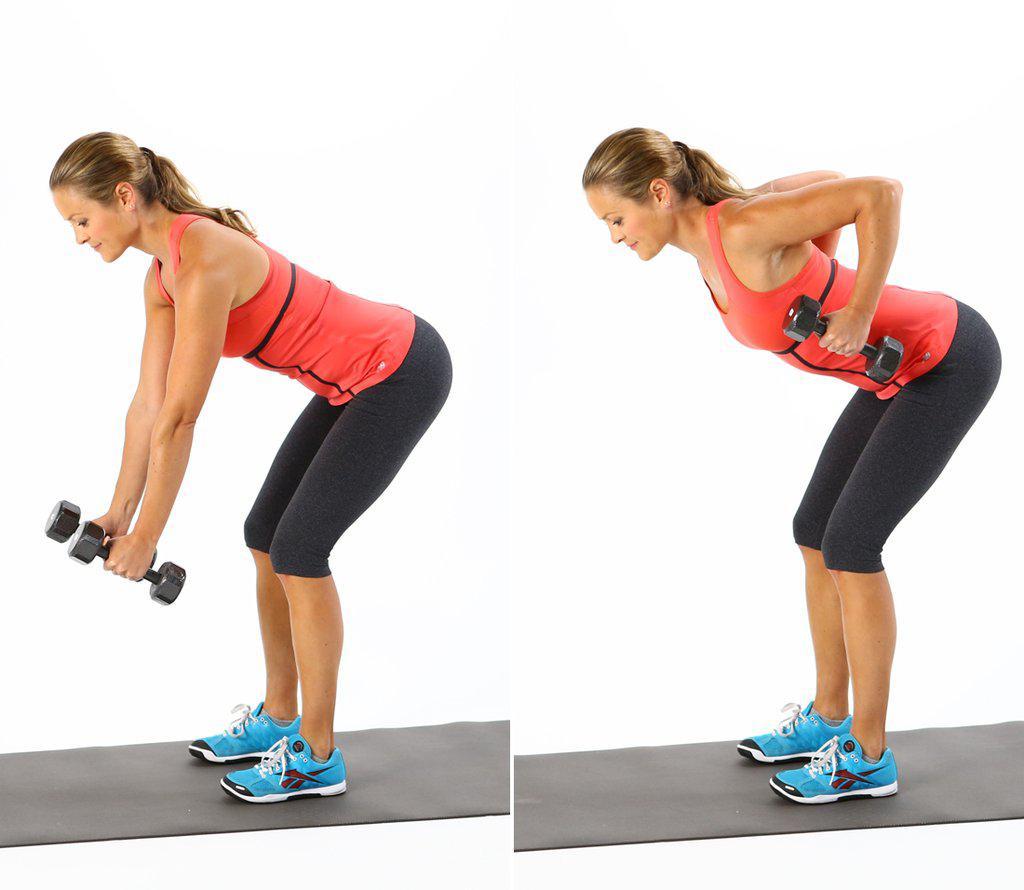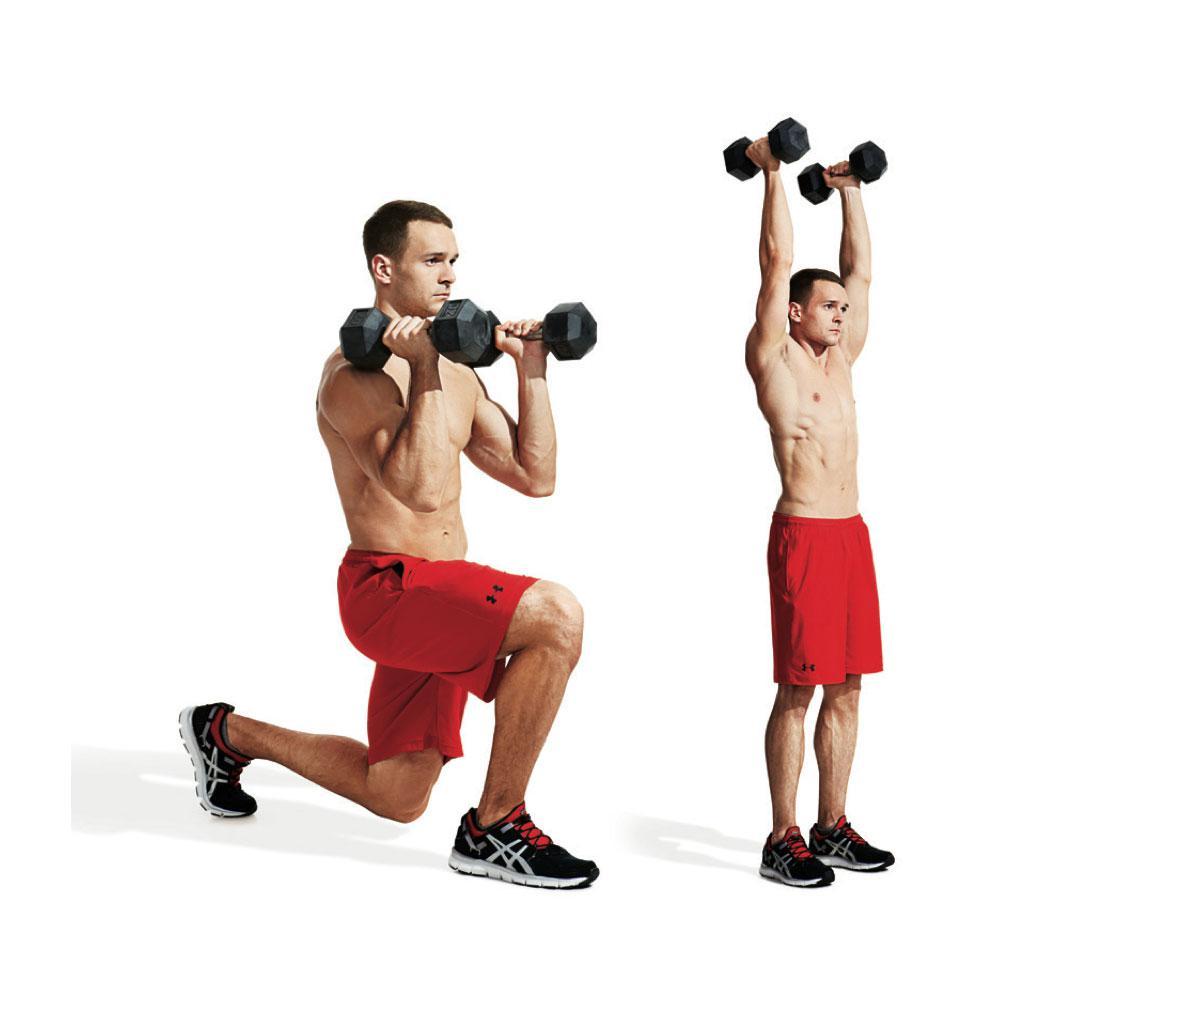The first image is the image on the left, the second image is the image on the right. For the images displayed, is the sentence "There is both a man and a woman demonstrating weight lifting techniques." factually correct? Answer yes or no. Yes. 